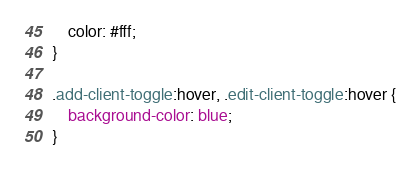Convert code to text. <code><loc_0><loc_0><loc_500><loc_500><_CSS_>    color: #fff;
}

.add-client-toggle:hover, .edit-client-toggle:hover {
    background-color: blue;
}</code> 